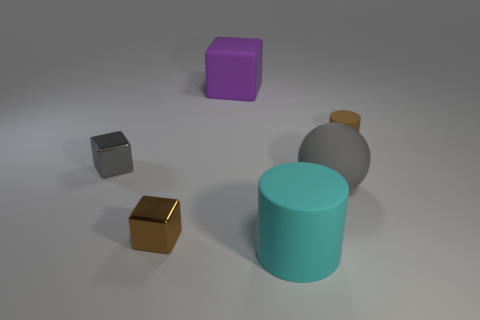Subtract all small cubes. How many cubes are left? 1 Subtract all brown cylinders. How many cylinders are left? 1 Subtract all balls. How many objects are left? 5 Add 4 large purple objects. How many objects exist? 10 Subtract 1 cylinders. How many cylinders are left? 1 Add 3 big rubber spheres. How many big rubber spheres exist? 4 Subtract 0 blue cylinders. How many objects are left? 6 Subtract all gray blocks. Subtract all purple cylinders. How many blocks are left? 2 Subtract all gray spheres. How many purple cubes are left? 1 Subtract all shiny blocks. Subtract all cyan cylinders. How many objects are left? 3 